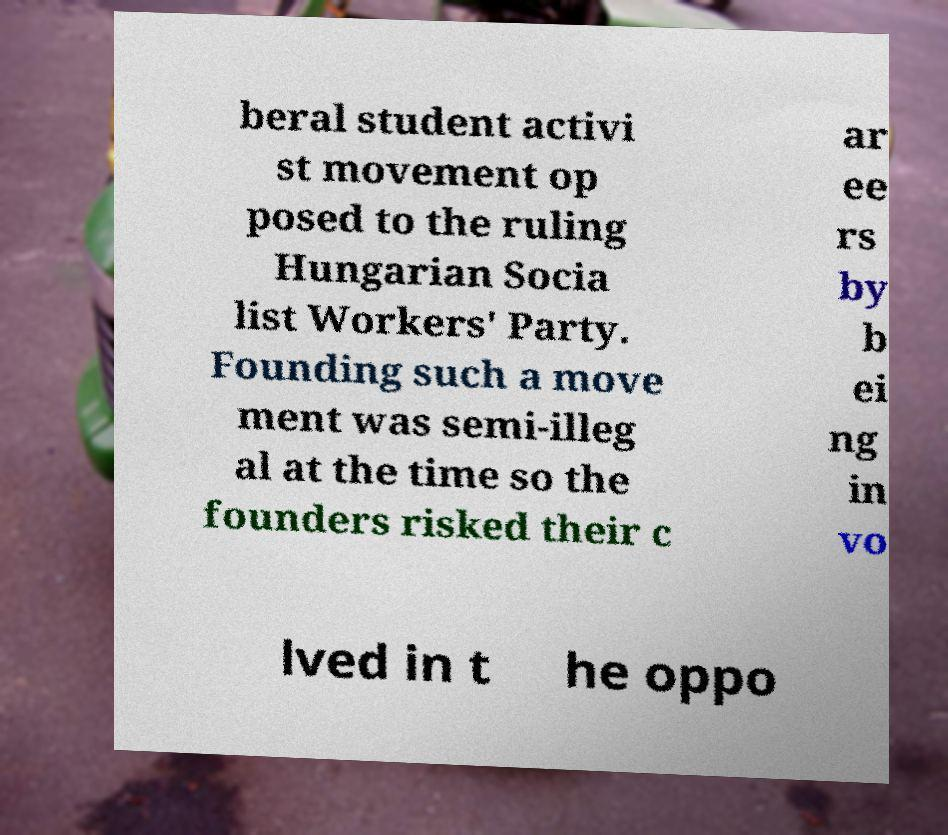Could you assist in decoding the text presented in this image and type it out clearly? beral student activi st movement op posed to the ruling Hungarian Socia list Workers' Party. Founding such a move ment was semi-illeg al at the time so the founders risked their c ar ee rs by b ei ng in vo lved in t he oppo 